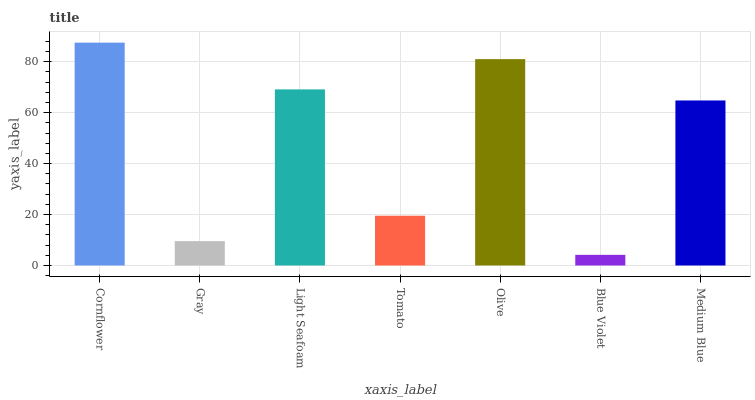Is Blue Violet the minimum?
Answer yes or no. Yes. Is Cornflower the maximum?
Answer yes or no. Yes. Is Gray the minimum?
Answer yes or no. No. Is Gray the maximum?
Answer yes or no. No. Is Cornflower greater than Gray?
Answer yes or no. Yes. Is Gray less than Cornflower?
Answer yes or no. Yes. Is Gray greater than Cornflower?
Answer yes or no. No. Is Cornflower less than Gray?
Answer yes or no. No. Is Medium Blue the high median?
Answer yes or no. Yes. Is Medium Blue the low median?
Answer yes or no. Yes. Is Tomato the high median?
Answer yes or no. No. Is Olive the low median?
Answer yes or no. No. 